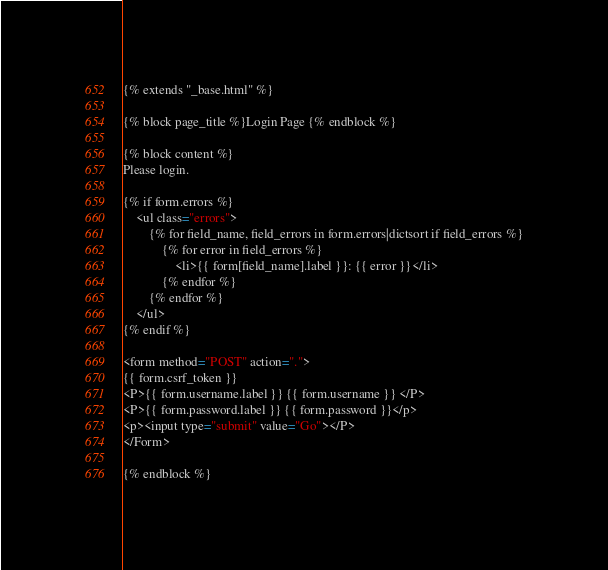<code> <loc_0><loc_0><loc_500><loc_500><_HTML_>{% extends "_base.html" %}

{% block page_title %}Login Page {% endblock %}

{% block content %}
Please login.

{% if form.errors %}
    <ul class="errors">
        {% for field_name, field_errors in form.errors|dictsort if field_errors %}
            {% for error in field_errors %}
                <li>{{ form[field_name].label }}: {{ error }}</li>
            {% endfor %}
        {% endfor %}
    </ul>
{% endif %}

<form method="POST" action=".">
{{ form.csrf_token }}
<P>{{ form.username.label }} {{ form.username }} </P> 
<P>{{ form.password.label }} {{ form.password }}</p>
<p><input type="submit" value="Go"></P>
</Form>

{% endblock %}



</code> 